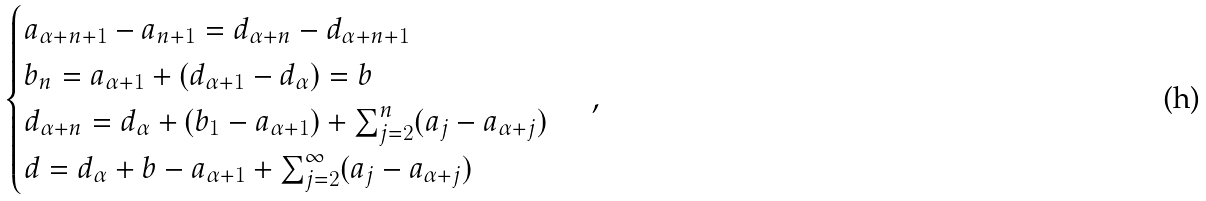<formula> <loc_0><loc_0><loc_500><loc_500>\begin{cases} a _ { \alpha + n + 1 } - a _ { n + 1 } = d _ { \alpha + n } - d _ { \alpha + n + 1 } \\ b _ { n } = a _ { \alpha + 1 } + ( d _ { \alpha + 1 } - d _ { \alpha } ) = b \\ d _ { \alpha + n } = d _ { \alpha } + ( b _ { 1 } - a _ { \alpha + 1 } ) + \sum _ { j = 2 } ^ { n } ( a _ { j } - a _ { \alpha + j } ) \\ d = d _ { \alpha } + b - a _ { \alpha + 1 } + \sum _ { j = 2 } ^ { \infty } ( a _ { j } - a _ { \alpha + j } ) \end{cases} \ ,</formula> 